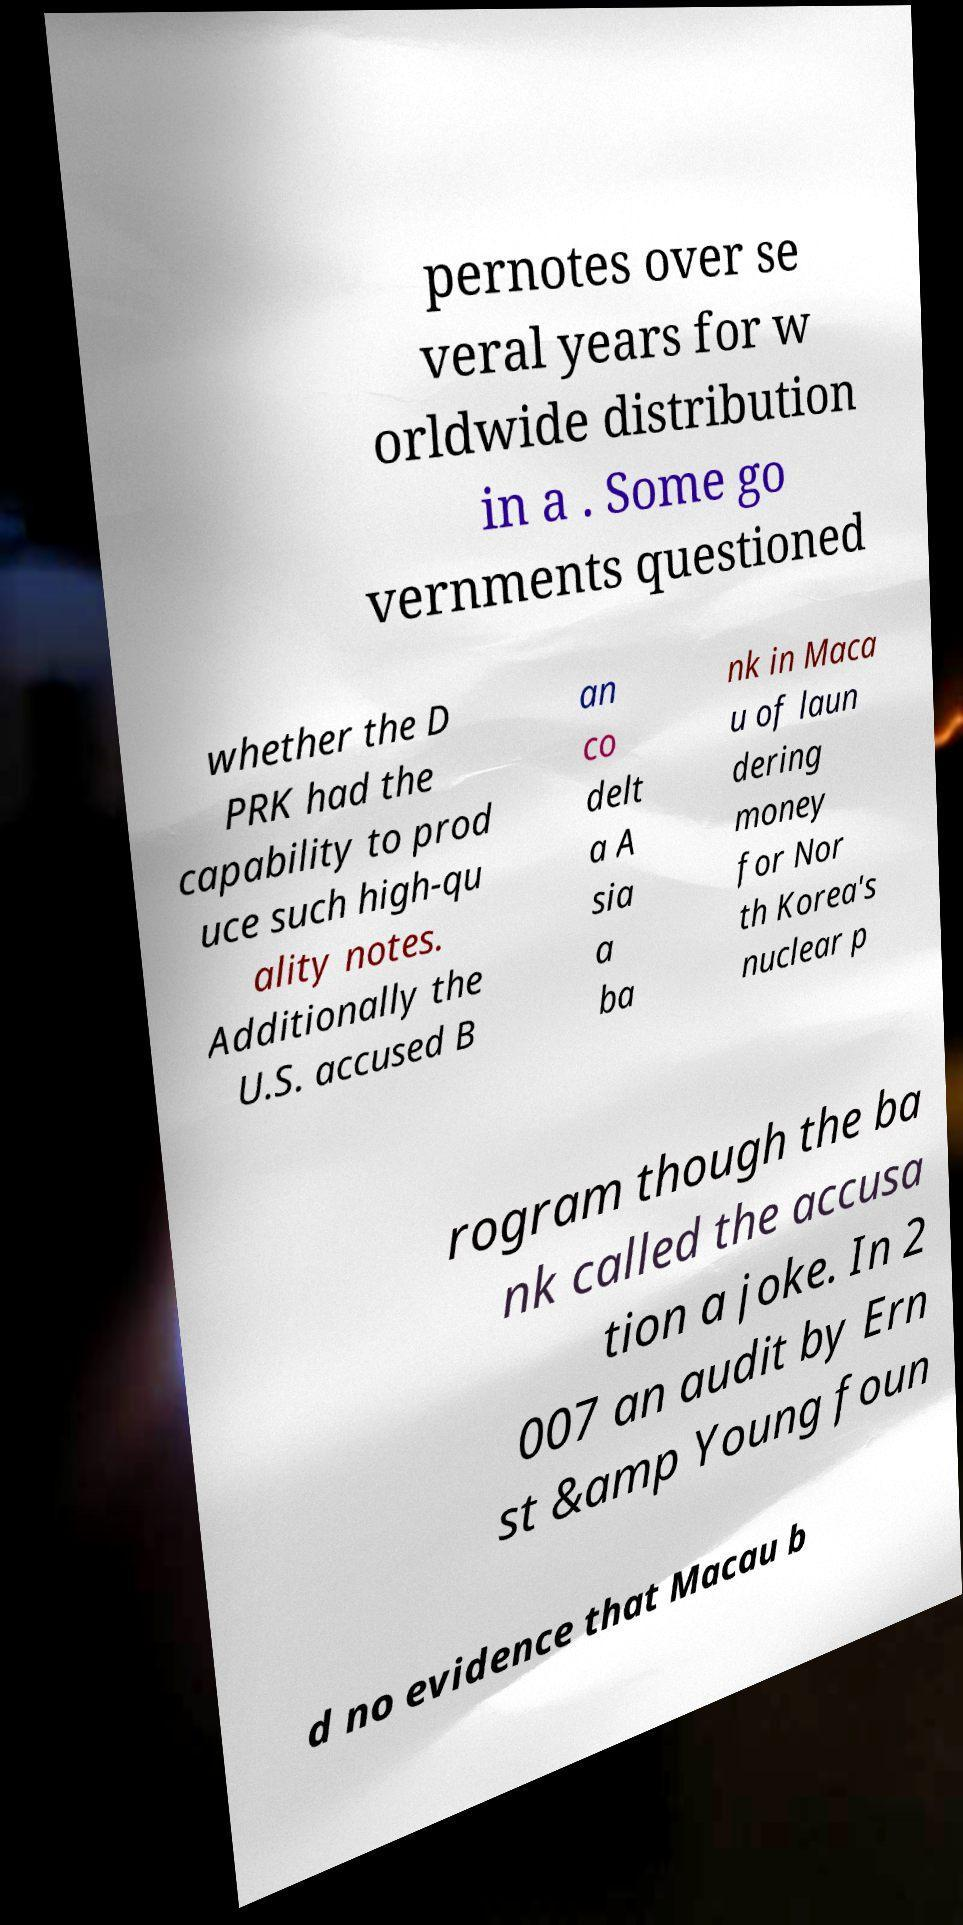Can you accurately transcribe the text from the provided image for me? pernotes over se veral years for w orldwide distribution in a . Some go vernments questioned whether the D PRK had the capability to prod uce such high-qu ality notes. Additionally the U.S. accused B an co delt a A sia a ba nk in Maca u of laun dering money for Nor th Korea's nuclear p rogram though the ba nk called the accusa tion a joke. In 2 007 an audit by Ern st &amp Young foun d no evidence that Macau b 